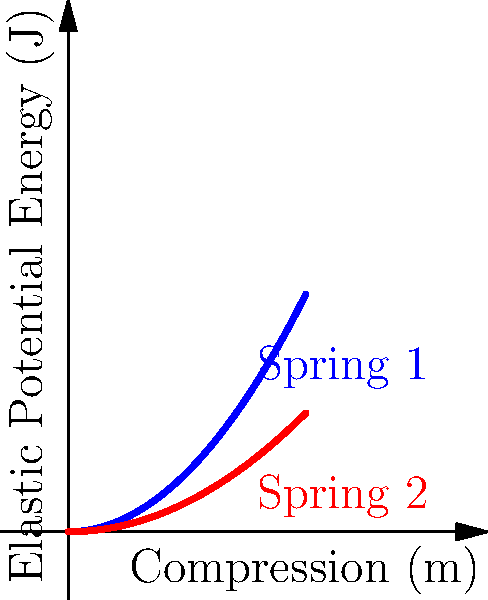As a dog show judge familiar with various agility equipment, you're evaluating two types of jumps with different spring constants. Jump A uses a spring with $k_1 = 1000$ N/m, while Jump B uses a spring with $k_2 = 500$ N/m. If both jumps are compressed by 0.5 m, what is the ratio of elastic potential energy stored in Jump A to Jump B? Let's approach this step-by-step:

1) The formula for elastic potential energy is:
   $$U = \frac{1}{2}kx^2$$
   where $k$ is the spring constant and $x$ is the compression.

2) For Jump A:
   $k_1 = 1000$ N/m, $x = 0.5$ m
   $$U_A = \frac{1}{2}(1000)(0.5)^2 = 125 \text{ J}$$

3) For Jump B:
   $k_2 = 500$ N/m, $x = 0.5$ m
   $$U_B = \frac{1}{2}(500)(0.5)^2 = 62.5 \text{ J}$$

4) The ratio of elastic potential energy in Jump A to Jump B is:
   $$\frac{U_A}{U_B} = \frac{125}{62.5} = 2$$

This result aligns with the graph, where we can see that for any given compression, the energy stored in Spring 1 (Jump A) is twice that of Spring 2 (Jump B).
Answer: 2:1 